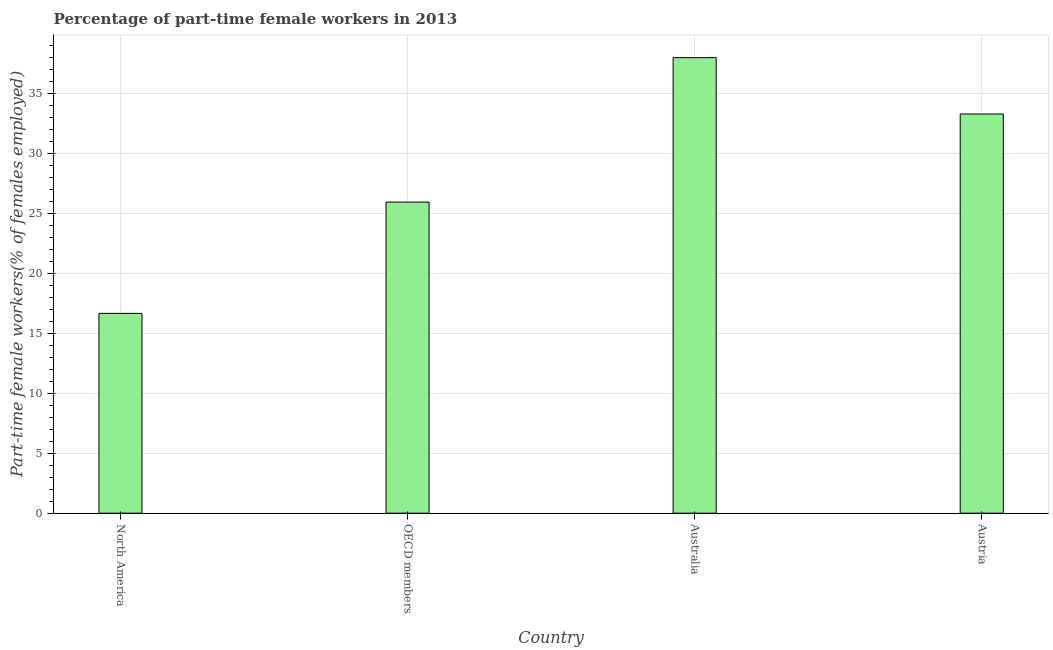Does the graph contain any zero values?
Keep it short and to the point. No. What is the title of the graph?
Your response must be concise. Percentage of part-time female workers in 2013. What is the label or title of the X-axis?
Provide a succinct answer. Country. What is the label or title of the Y-axis?
Make the answer very short. Part-time female workers(% of females employed). What is the percentage of part-time female workers in Austria?
Your answer should be compact. 33.3. Across all countries, what is the minimum percentage of part-time female workers?
Give a very brief answer. 16.67. In which country was the percentage of part-time female workers maximum?
Give a very brief answer. Australia. In which country was the percentage of part-time female workers minimum?
Ensure brevity in your answer.  North America. What is the sum of the percentage of part-time female workers?
Offer a terse response. 113.92. What is the difference between the percentage of part-time female workers in Australia and Austria?
Make the answer very short. 4.7. What is the average percentage of part-time female workers per country?
Your answer should be compact. 28.48. What is the median percentage of part-time female workers?
Offer a terse response. 29.63. What is the ratio of the percentage of part-time female workers in Austria to that in OECD members?
Keep it short and to the point. 1.28. Is the percentage of part-time female workers in Austria less than that in North America?
Give a very brief answer. No. What is the difference between the highest and the second highest percentage of part-time female workers?
Give a very brief answer. 4.7. Is the sum of the percentage of part-time female workers in Australia and Austria greater than the maximum percentage of part-time female workers across all countries?
Keep it short and to the point. Yes. What is the difference between the highest and the lowest percentage of part-time female workers?
Make the answer very short. 21.33. Are all the bars in the graph horizontal?
Your answer should be compact. No. What is the Part-time female workers(% of females employed) in North America?
Your response must be concise. 16.67. What is the Part-time female workers(% of females employed) in OECD members?
Provide a short and direct response. 25.95. What is the Part-time female workers(% of females employed) in Australia?
Make the answer very short. 38. What is the Part-time female workers(% of females employed) of Austria?
Offer a very short reply. 33.3. What is the difference between the Part-time female workers(% of females employed) in North America and OECD members?
Provide a short and direct response. -9.29. What is the difference between the Part-time female workers(% of females employed) in North America and Australia?
Keep it short and to the point. -21.33. What is the difference between the Part-time female workers(% of females employed) in North America and Austria?
Make the answer very short. -16.63. What is the difference between the Part-time female workers(% of females employed) in OECD members and Australia?
Provide a short and direct response. -12.05. What is the difference between the Part-time female workers(% of females employed) in OECD members and Austria?
Provide a short and direct response. -7.35. What is the ratio of the Part-time female workers(% of females employed) in North America to that in OECD members?
Give a very brief answer. 0.64. What is the ratio of the Part-time female workers(% of females employed) in North America to that in Australia?
Ensure brevity in your answer.  0.44. What is the ratio of the Part-time female workers(% of females employed) in North America to that in Austria?
Your answer should be compact. 0.5. What is the ratio of the Part-time female workers(% of females employed) in OECD members to that in Australia?
Provide a short and direct response. 0.68. What is the ratio of the Part-time female workers(% of females employed) in OECD members to that in Austria?
Your answer should be very brief. 0.78. What is the ratio of the Part-time female workers(% of females employed) in Australia to that in Austria?
Provide a short and direct response. 1.14. 